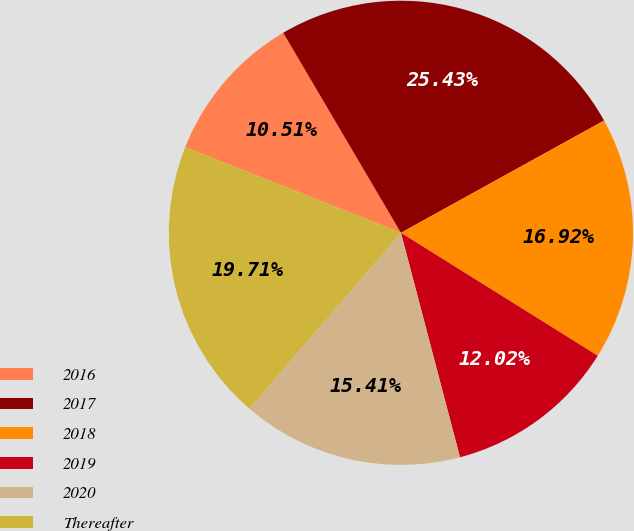Convert chart to OTSL. <chart><loc_0><loc_0><loc_500><loc_500><pie_chart><fcel>2016<fcel>2017<fcel>2018<fcel>2019<fcel>2020<fcel>Thereafter<nl><fcel>10.51%<fcel>25.43%<fcel>16.92%<fcel>12.02%<fcel>15.41%<fcel>19.71%<nl></chart> 